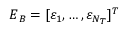<formula> <loc_0><loc_0><loc_500><loc_500>E _ { B } = [ \varepsilon _ { 1 } , \dots , \varepsilon _ { N _ { T } } ] ^ { T }</formula> 